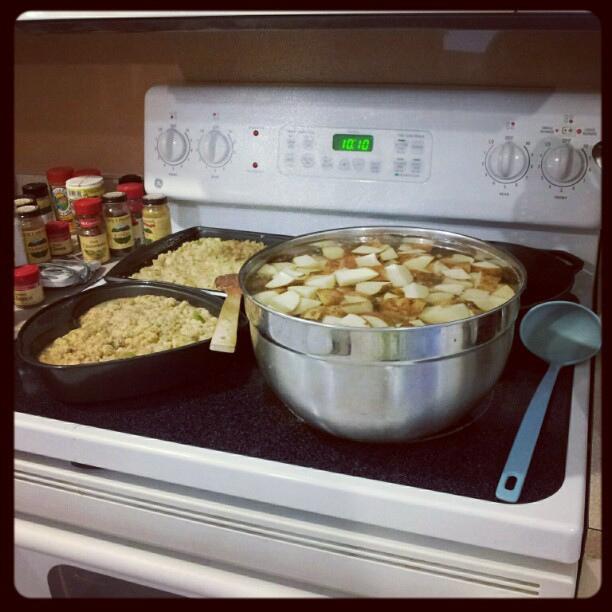What time is it on the stove clock?
Keep it brief. 10:10. How long does it take to boil potatoes?
Concise answer only. 20 minutes. Is this a healthy meal?
Be succinct. Yes. What food is on the stove?
Give a very brief answer. Potatoes. Is a spoon needed?
Answer briefly. Yes. Is there a ladle in the picture?
Answer briefly. Yes. 